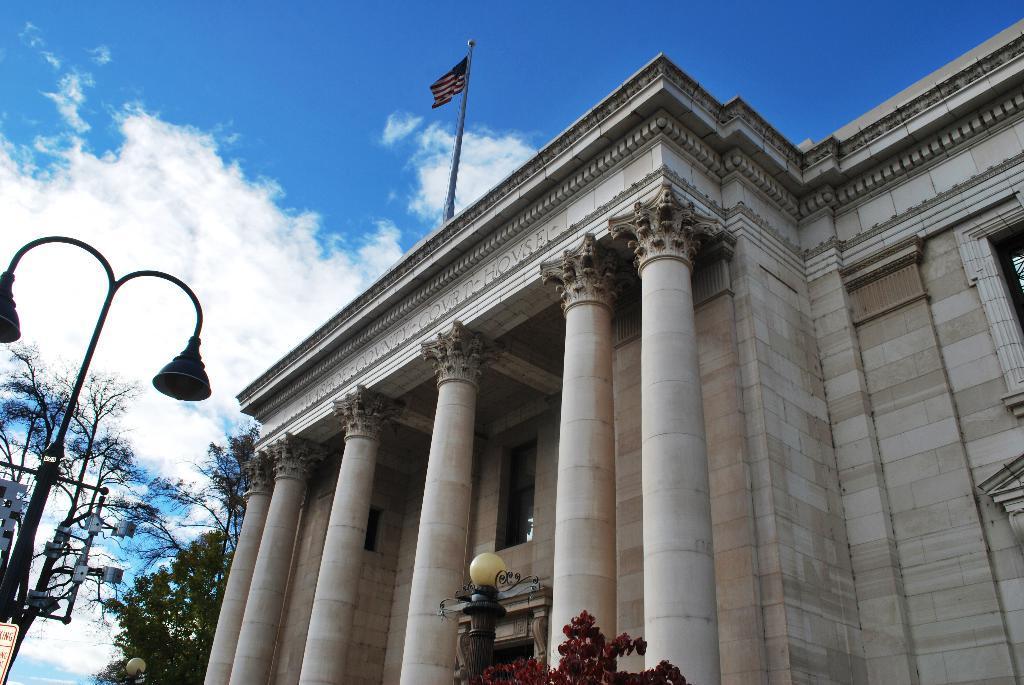How would you summarize this image in a sentence or two? In this image we can see a building with pillars, lights in front of the building, trees beside the building and sky in the background. 